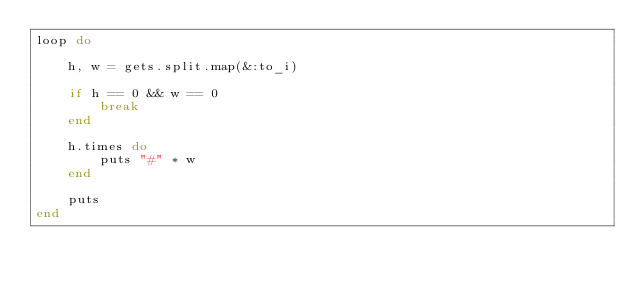<code> <loc_0><loc_0><loc_500><loc_500><_Ruby_>loop do

    h, w = gets.split.map(&:to_i)

    if h == 0 && w == 0
        break
    end

    h.times do
        puts "#" * w
    end

    puts
end</code> 